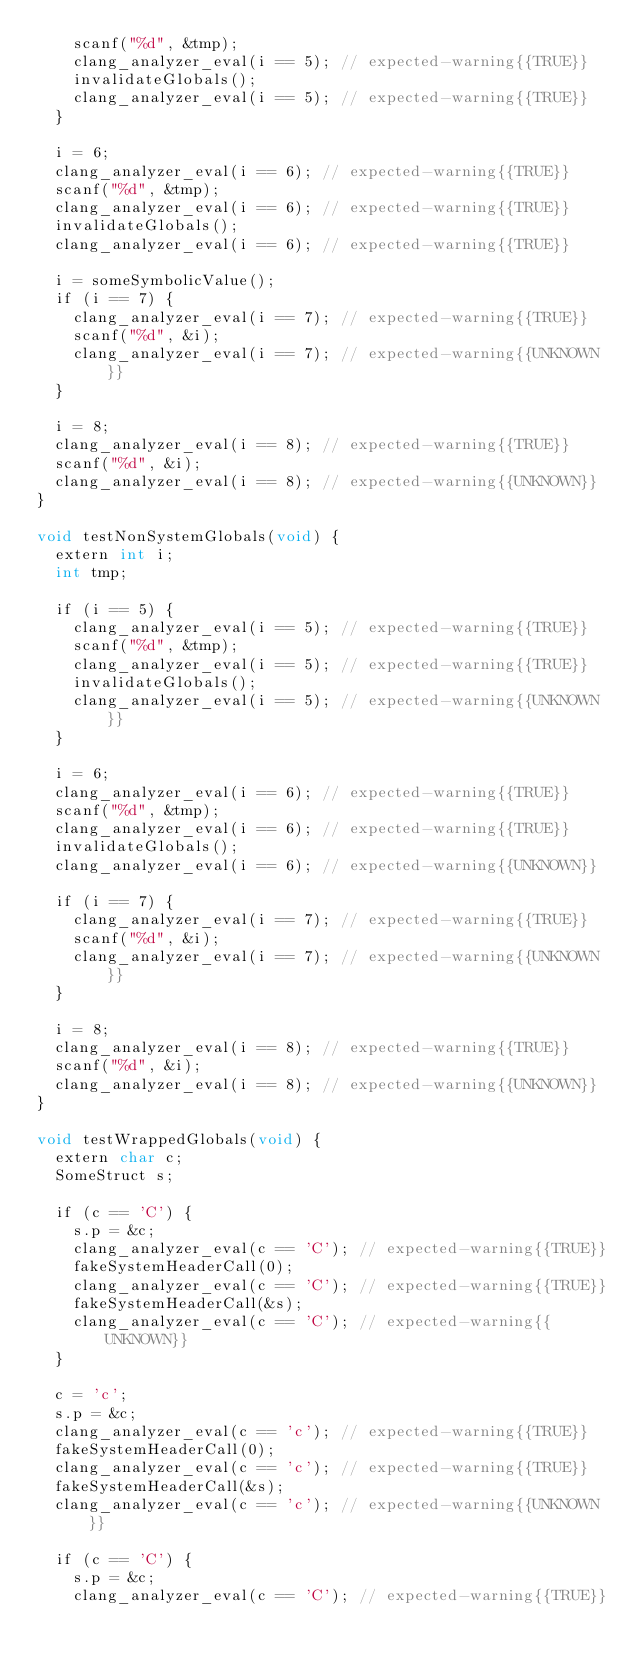<code> <loc_0><loc_0><loc_500><loc_500><_ObjectiveC_>    scanf("%d", &tmp);
    clang_analyzer_eval(i == 5); // expected-warning{{TRUE}}
    invalidateGlobals();
    clang_analyzer_eval(i == 5); // expected-warning{{TRUE}}
  }

  i = 6;
  clang_analyzer_eval(i == 6); // expected-warning{{TRUE}}
  scanf("%d", &tmp);
  clang_analyzer_eval(i == 6); // expected-warning{{TRUE}}
  invalidateGlobals();
  clang_analyzer_eval(i == 6); // expected-warning{{TRUE}}

  i = someSymbolicValue();
  if (i == 7) {
    clang_analyzer_eval(i == 7); // expected-warning{{TRUE}}
    scanf("%d", &i);
    clang_analyzer_eval(i == 7); // expected-warning{{UNKNOWN}}
  }

  i = 8;
  clang_analyzer_eval(i == 8); // expected-warning{{TRUE}}
  scanf("%d", &i);
  clang_analyzer_eval(i == 8); // expected-warning{{UNKNOWN}}
}

void testNonSystemGlobals(void) {
  extern int i;
  int tmp;

  if (i == 5) {
    clang_analyzer_eval(i == 5); // expected-warning{{TRUE}}
    scanf("%d", &tmp);
    clang_analyzer_eval(i == 5); // expected-warning{{TRUE}}
    invalidateGlobals();
    clang_analyzer_eval(i == 5); // expected-warning{{UNKNOWN}}
  }

  i = 6;
  clang_analyzer_eval(i == 6); // expected-warning{{TRUE}}
  scanf("%d", &tmp);
  clang_analyzer_eval(i == 6); // expected-warning{{TRUE}}
  invalidateGlobals();
  clang_analyzer_eval(i == 6); // expected-warning{{UNKNOWN}}

  if (i == 7) {
    clang_analyzer_eval(i == 7); // expected-warning{{TRUE}}
    scanf("%d", &i);
    clang_analyzer_eval(i == 7); // expected-warning{{UNKNOWN}}
  }

  i = 8;
  clang_analyzer_eval(i == 8); // expected-warning{{TRUE}}
  scanf("%d", &i);
  clang_analyzer_eval(i == 8); // expected-warning{{UNKNOWN}}
}

void testWrappedGlobals(void) {
  extern char c;
  SomeStruct s;

  if (c == 'C') {
    s.p = &c;
    clang_analyzer_eval(c == 'C'); // expected-warning{{TRUE}}
    fakeSystemHeaderCall(0);
    clang_analyzer_eval(c == 'C'); // expected-warning{{TRUE}}
    fakeSystemHeaderCall(&s);
    clang_analyzer_eval(c == 'C'); // expected-warning{{UNKNOWN}}
  }

  c = 'c';
  s.p = &c;
  clang_analyzer_eval(c == 'c'); // expected-warning{{TRUE}}
  fakeSystemHeaderCall(0);
  clang_analyzer_eval(c == 'c'); // expected-warning{{TRUE}}
  fakeSystemHeaderCall(&s);
  clang_analyzer_eval(c == 'c'); // expected-warning{{UNKNOWN}}

  if (c == 'C') {
    s.p = &c;
    clang_analyzer_eval(c == 'C'); // expected-warning{{TRUE}}</code> 